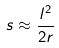<formula> <loc_0><loc_0><loc_500><loc_500>s \approx \frac { l ^ { 2 } } { 2 r }</formula> 